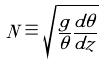<formula> <loc_0><loc_0><loc_500><loc_500>N \equiv \sqrt { \frac { g } { \theta } \frac { d \theta } { d z } }</formula> 